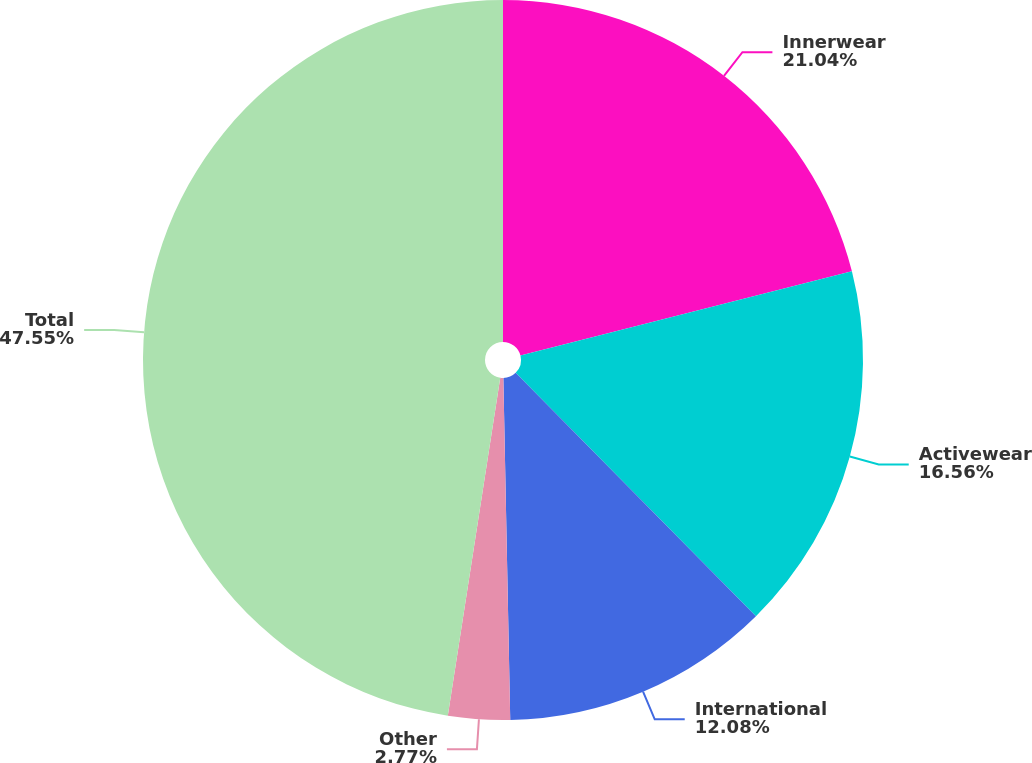Convert chart. <chart><loc_0><loc_0><loc_500><loc_500><pie_chart><fcel>Innerwear<fcel>Activewear<fcel>International<fcel>Other<fcel>Total<nl><fcel>21.04%<fcel>16.56%<fcel>12.08%<fcel>2.77%<fcel>47.55%<nl></chart> 